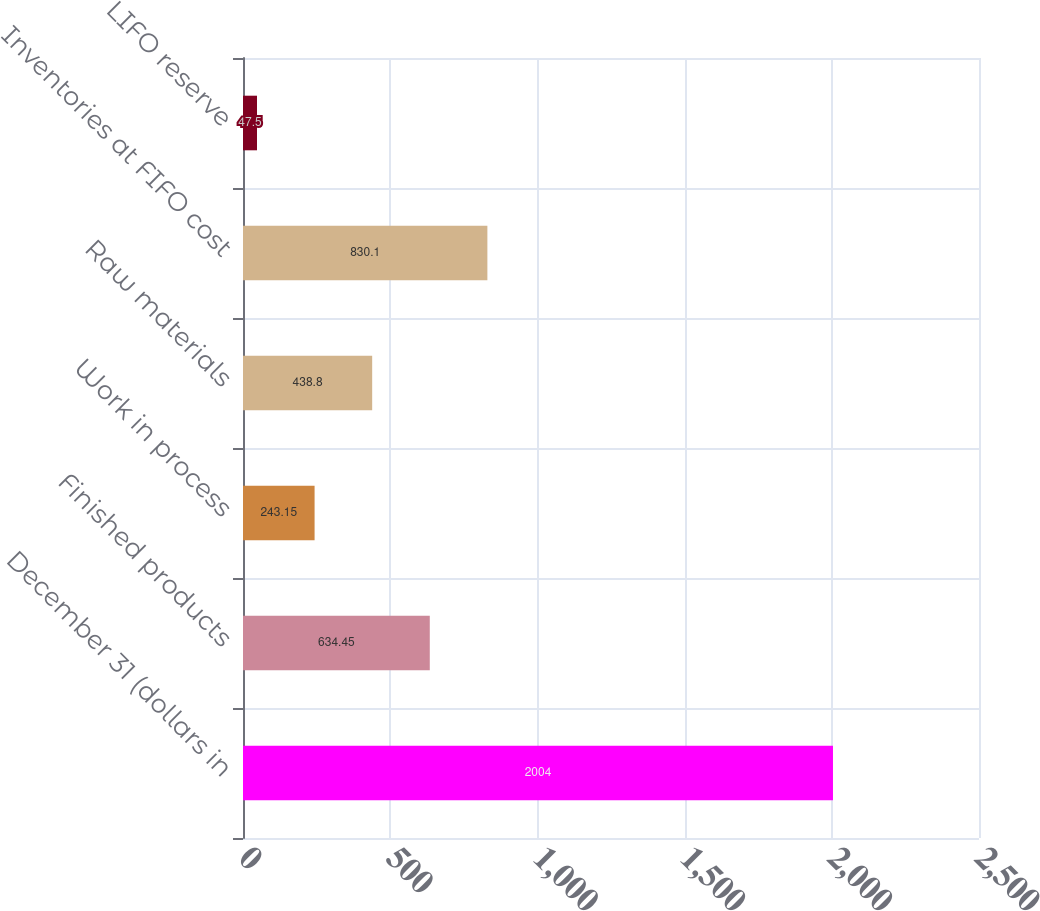Convert chart. <chart><loc_0><loc_0><loc_500><loc_500><bar_chart><fcel>December 31 (dollars in<fcel>Finished products<fcel>Work in process<fcel>Raw materials<fcel>Inventories at FIFO cost<fcel>LIFO reserve<nl><fcel>2004<fcel>634.45<fcel>243.15<fcel>438.8<fcel>830.1<fcel>47.5<nl></chart> 